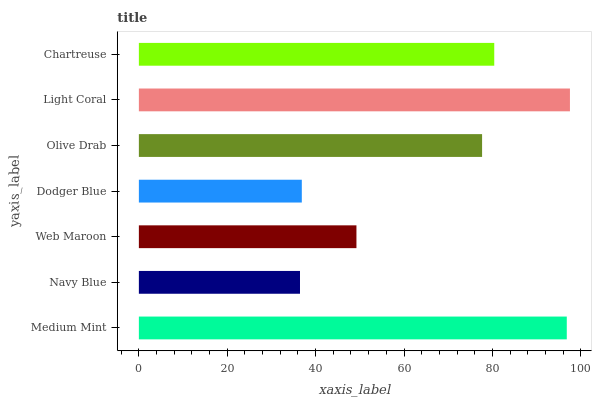Is Navy Blue the minimum?
Answer yes or no. Yes. Is Light Coral the maximum?
Answer yes or no. Yes. Is Web Maroon the minimum?
Answer yes or no. No. Is Web Maroon the maximum?
Answer yes or no. No. Is Web Maroon greater than Navy Blue?
Answer yes or no. Yes. Is Navy Blue less than Web Maroon?
Answer yes or no. Yes. Is Navy Blue greater than Web Maroon?
Answer yes or no. No. Is Web Maroon less than Navy Blue?
Answer yes or no. No. Is Olive Drab the high median?
Answer yes or no. Yes. Is Olive Drab the low median?
Answer yes or no. Yes. Is Navy Blue the high median?
Answer yes or no. No. Is Dodger Blue the low median?
Answer yes or no. No. 